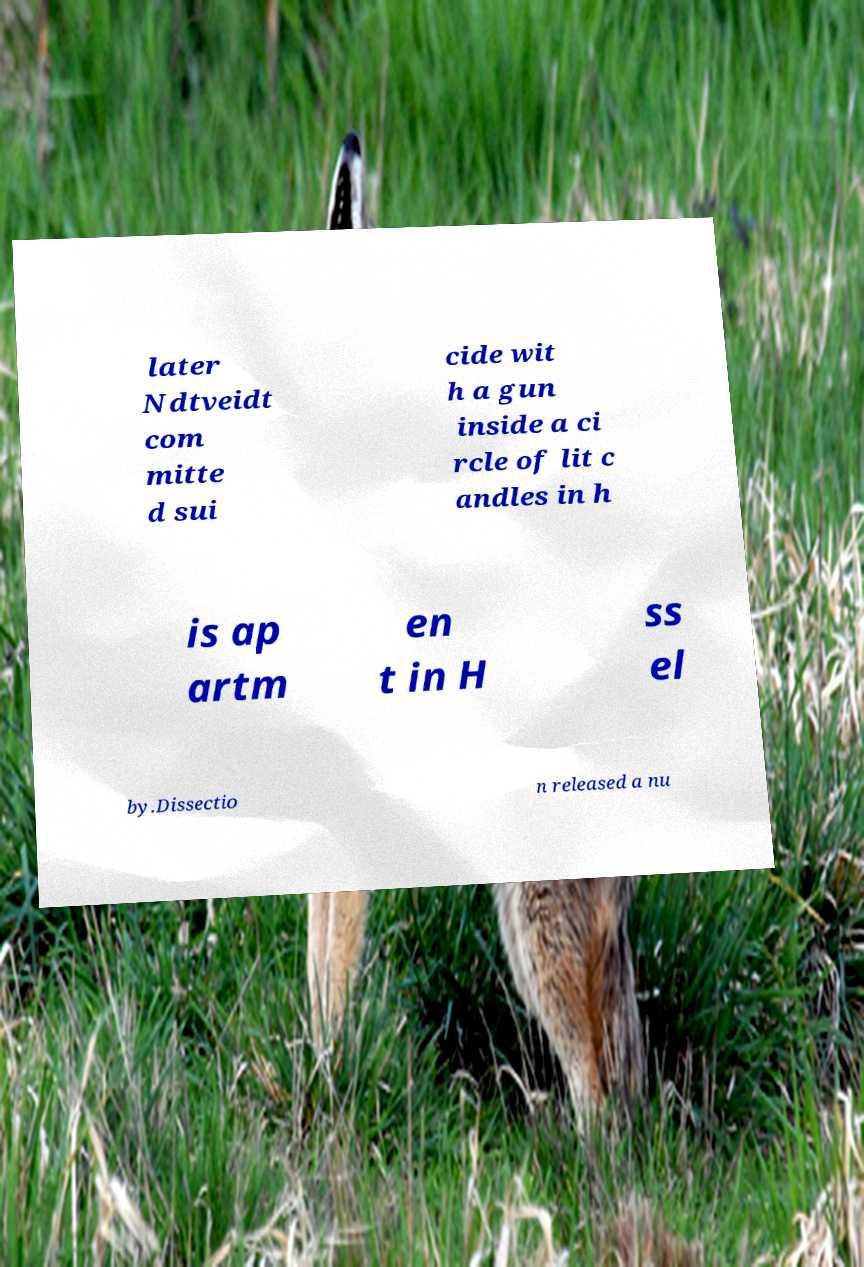What messages or text are displayed in this image? I need them in a readable, typed format. later Ndtveidt com mitte d sui cide wit h a gun inside a ci rcle of lit c andles in h is ap artm en t in H ss el by.Dissectio n released a nu 